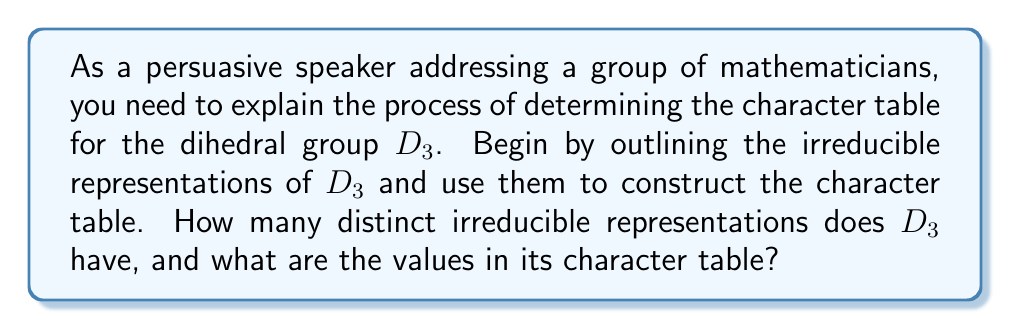Can you answer this question? To determine the character table of $D_3$, we'll follow these steps:

1) First, recall that $D_3$ is the symmetry group of an equilateral triangle, with 6 elements: 
   $\{e, r, r^2, s, sr, sr^2\}$, where $e$ is the identity, $r$ is a 120° rotation, and $s$ is a reflection.

2) To find the number of irreducible representations, we use the formula:
   $$\text{Number of irreducible representations} = \text{Number of conjugacy classes}$$

3) The conjugacy classes of $D_3$ are:
   $\{e\}$, $\{r, r^2\}$, $\{s, sr, sr^2\}$
   So, $D_3$ has 3 irreducible representations.

4) The sum of the squares of the dimensions of these representations must equal the order of the group:
   $$d_1^2 + d_2^2 + d_3^2 = |D_3| = 6$$

5) We know there's always a 1-dimensional trivial representation. The only solution is:
   $d_1 = 1$, $d_2 = 1$, $d_3 = 2$

6) Now, let's construct the character table:
   - $\chi_1$ is the trivial representation: all characters are 1
   - $\chi_2$ is the sign representation: 1 for even permutations, -1 for odd
   - $\chi_3$ is the 2-dimensional representation

7) For $\chi_3$, we can deduce:
   - $\chi_3(e) = 2$ (trace of 2x2 identity matrix)
   - $\chi_3(r) = -1$ (trace of 120° rotation matrix)
   - $\chi_3(s) = 0$ (trace of reflection matrix)

8) The completed character table:

   $$\begin{array}{c|ccc}
      & \{e\} & \{r,r^2\} & \{s,sr,sr^2\} \\
      \hline
      \chi_1 & 1 & 1 & 1 \\
      \chi_2 & 1 & 1 & -1 \\
      \chi_3 & 2 & -1 & 0
   \end{array}$$
Answer: $D_3$ has 3 irreducible representations. Character table:
$$\begin{array}{c|ccc}
   & \{e\} & \{r,r^2\} & \{s,sr,sr^2\} \\
   \hline
   \chi_1 & 1 & 1 & 1 \\
   \chi_2 & 1 & 1 & -1 \\
   \chi_3 & 2 & -1 & 0
\end{array}$$ 